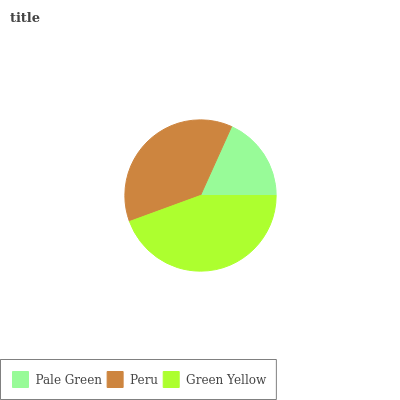Is Pale Green the minimum?
Answer yes or no. Yes. Is Green Yellow the maximum?
Answer yes or no. Yes. Is Peru the minimum?
Answer yes or no. No. Is Peru the maximum?
Answer yes or no. No. Is Peru greater than Pale Green?
Answer yes or no. Yes. Is Pale Green less than Peru?
Answer yes or no. Yes. Is Pale Green greater than Peru?
Answer yes or no. No. Is Peru less than Pale Green?
Answer yes or no. No. Is Peru the high median?
Answer yes or no. Yes. Is Peru the low median?
Answer yes or no. Yes. Is Pale Green the high median?
Answer yes or no. No. Is Pale Green the low median?
Answer yes or no. No. 